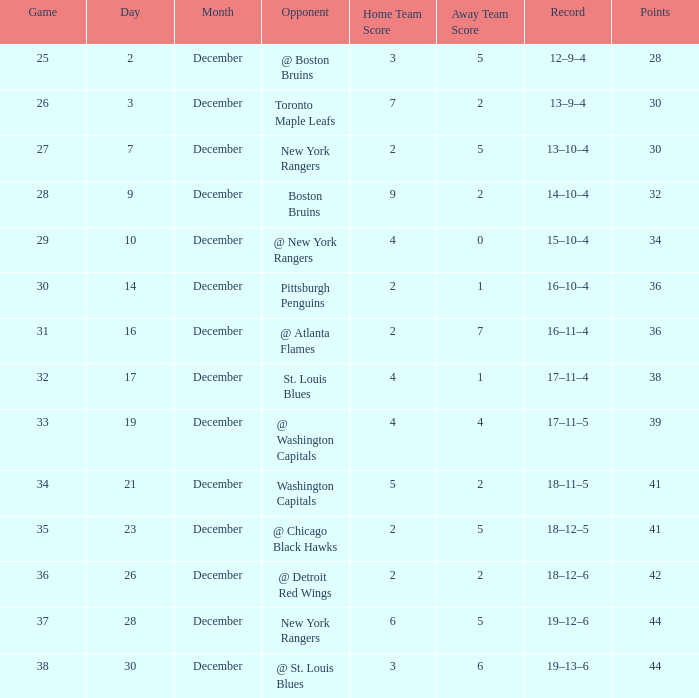Which game has a 14-10-4 record and a point total under 32? None. 